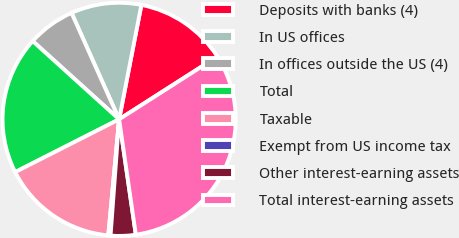Convert chart. <chart><loc_0><loc_0><loc_500><loc_500><pie_chart><fcel>Deposits with banks (4)<fcel>In US offices<fcel>In offices outside the US (4)<fcel>Total<fcel>Taxable<fcel>Exempt from US income tax<fcel>Other interest-earning assets<fcel>Total interest-earning assets<nl><fcel>12.89%<fcel>9.75%<fcel>6.6%<fcel>19.18%<fcel>16.04%<fcel>0.31%<fcel>3.46%<fcel>31.76%<nl></chart> 